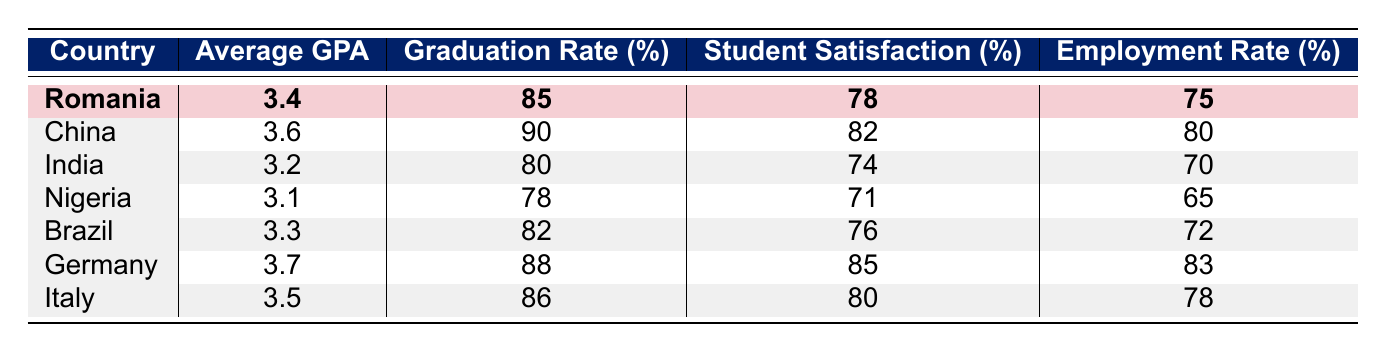What is the average GPA of international students from Romania? The table shows that the average GPA for Romania is specifically listed in the row corresponding to Romania, which is 3.4.
Answer: 3.4 Which country has the highest graduation rate? By examining the graduation rate column, we can see the highest rate is 90%, which corresponds to China.
Answer: China Is the student satisfaction rate from Nigeria higher than that from India? The table shows Nigeria's student satisfaction at 71% and India's at 74%. Since 71% is less than 74%, the satisfaction rate from Nigeria is not higher than from India.
Answer: No What is the difference in average GPA between Germany and Nigeria? The average GPA for Germany is 3.7 and for Nigeria is 3.1. The difference is calculated as 3.7 - 3.1 = 0.6.
Answer: 0.6 Which countries have an employment rate after graduation higher than 75%? Checking the employment rates, we find China (80%), Germany (83%), and Italy (78%) all have rates higher than 75%.
Answer: China, Germany, Italy What is the average employment rate of international students in this table? To find the average, we sum the employment rates: 75 + 80 + 70 + 65 + 72 + 83 + 78 = 453. Dividing by the number of countries (7), the average is 453 / 7 ≈ 64.71.
Answer: Approximately 64.71 Is the average GPA of students from Italy greater than the average GPA of students from Brazil? The average GPA for Italy is 3.5 and for Brazil is 3.3. Since 3.5 is greater than 3.3, Italy's GPA is indeed higher.
Answer: Yes Which country has both a higher graduation rate and higher student satisfaction than Romania? Romania's graduation rate is 85% and satisfaction is 78%. Looking at other countries, China has 90% and 82% respectively, and Germany has 88% and 85%. Both have higher figures.
Answer: China, Germany 